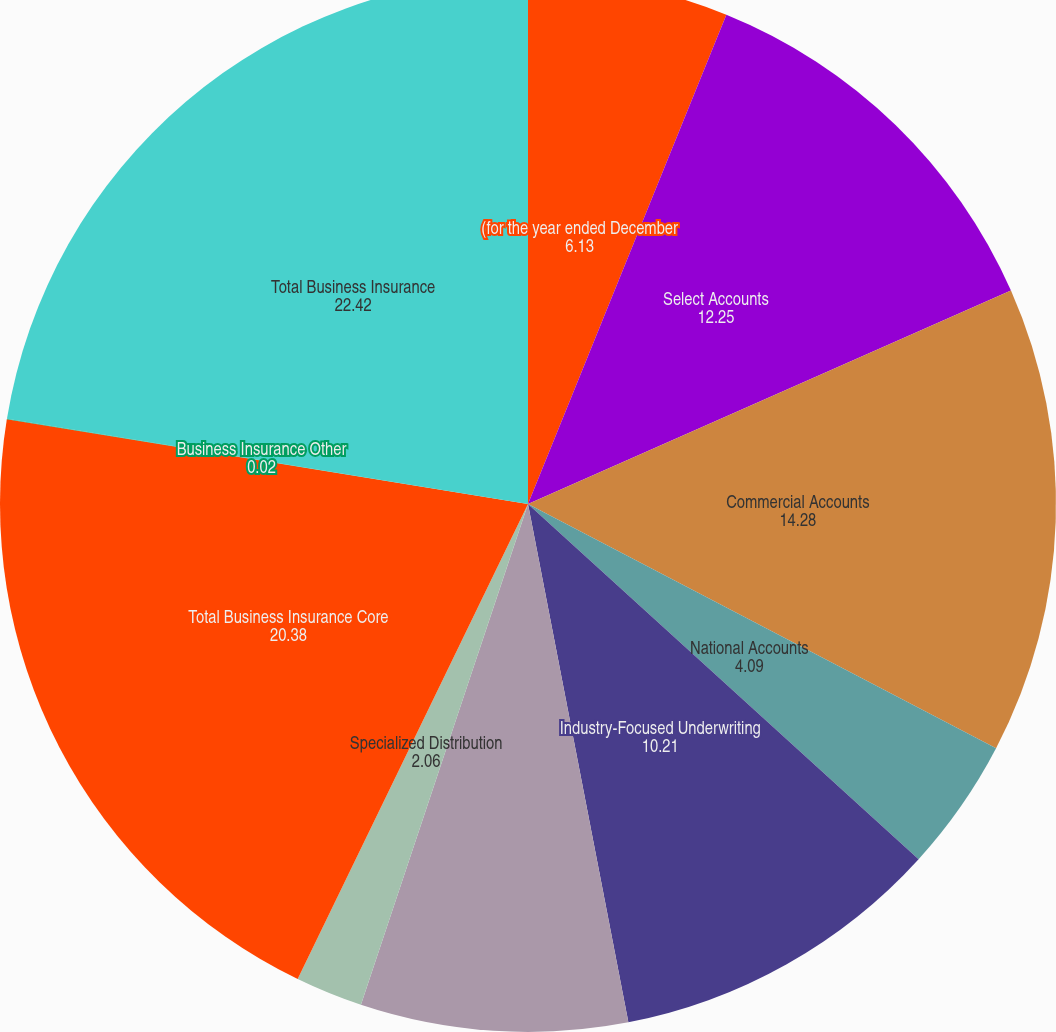<chart> <loc_0><loc_0><loc_500><loc_500><pie_chart><fcel>(for the year ended December<fcel>Select Accounts<fcel>Commercial Accounts<fcel>National Accounts<fcel>Industry-Focused Underwriting<fcel>Target Risk Underwriting<fcel>Specialized Distribution<fcel>Total Business Insurance Core<fcel>Business Insurance Other<fcel>Total Business Insurance<nl><fcel>6.13%<fcel>12.25%<fcel>14.28%<fcel>4.09%<fcel>10.21%<fcel>8.17%<fcel>2.06%<fcel>20.38%<fcel>0.02%<fcel>22.42%<nl></chart> 